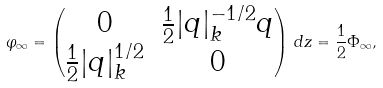<formula> <loc_0><loc_0><loc_500><loc_500>\varphi _ { \infty } = \begin{pmatrix} 0 & \frac { 1 } { 2 } | q | _ { k } ^ { - 1 / 2 } q \\ \frac { 1 } { 2 } | q | _ { k } ^ { 1 / 2 } & 0 \end{pmatrix} \, d z = \frac { 1 } { 2 } \Phi _ { \infty } ,</formula> 